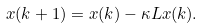<formula> <loc_0><loc_0><loc_500><loc_500>x ( k + 1 ) = x ( k ) - \kappa L x ( k ) .</formula> 